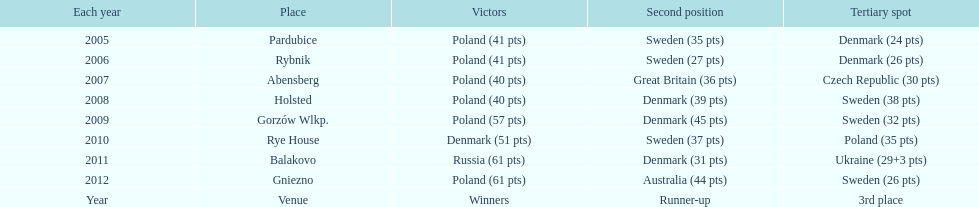When was the first year that poland did not place in the top three positions of the team speedway junior world championship? 2011. 